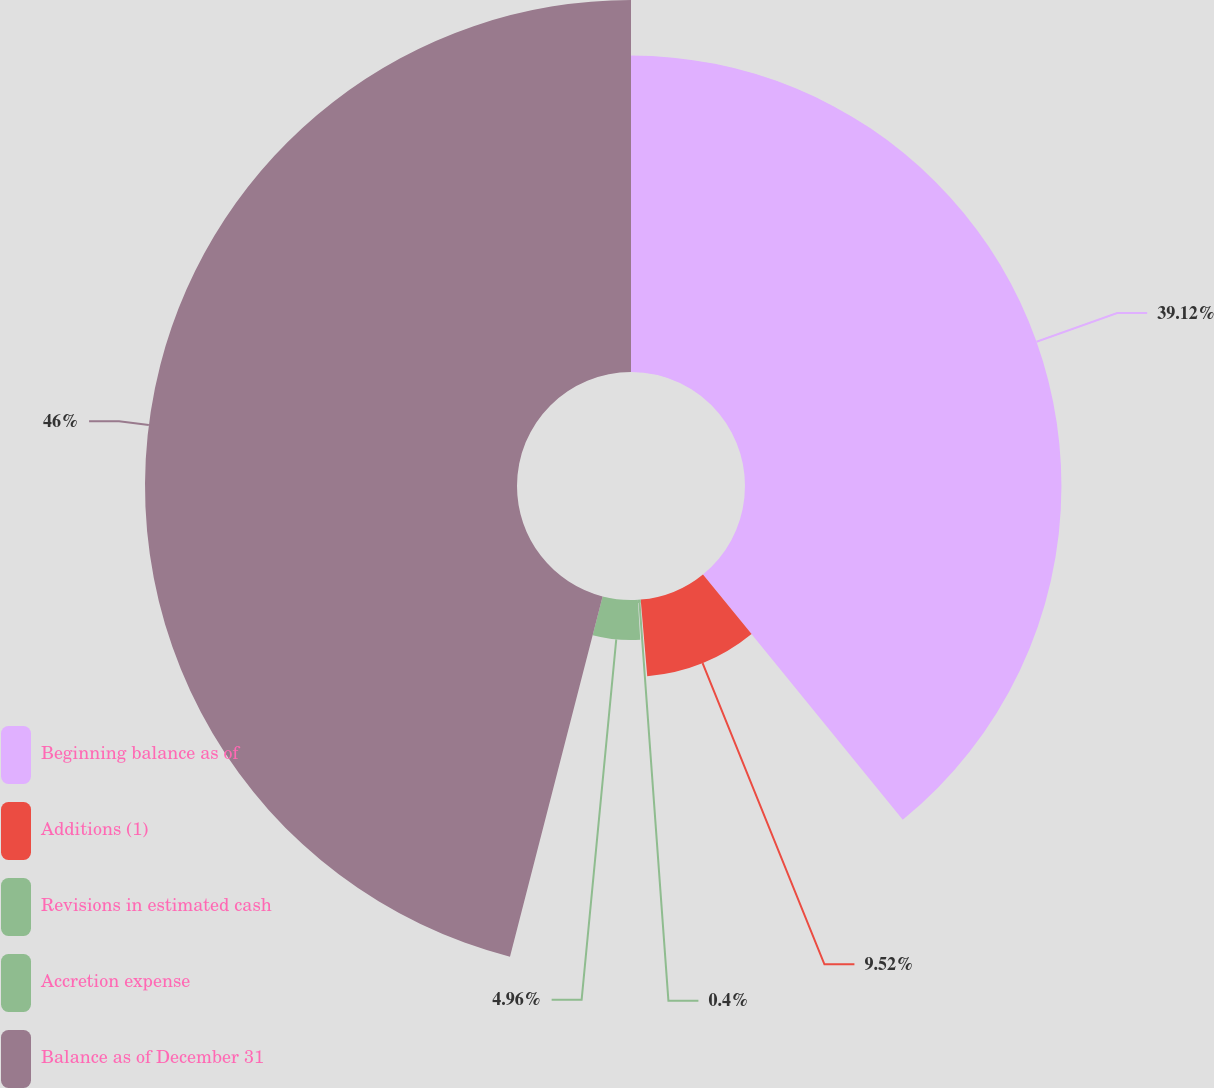<chart> <loc_0><loc_0><loc_500><loc_500><pie_chart><fcel>Beginning balance as of<fcel>Additions (1)<fcel>Revisions in estimated cash<fcel>Accretion expense<fcel>Balance as of December 31<nl><fcel>39.12%<fcel>9.52%<fcel>0.4%<fcel>4.96%<fcel>45.99%<nl></chart> 